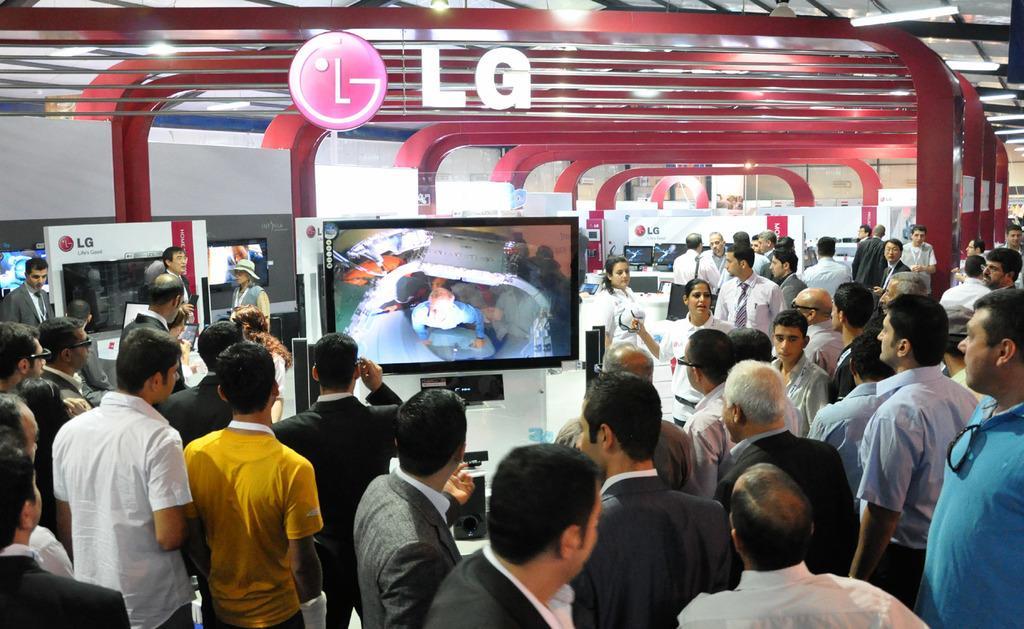In one or two sentences, can you explain what this image depicts? In this image we can see people standing. There are TV's. At the top of the image there is ceiling with rods and some text. 